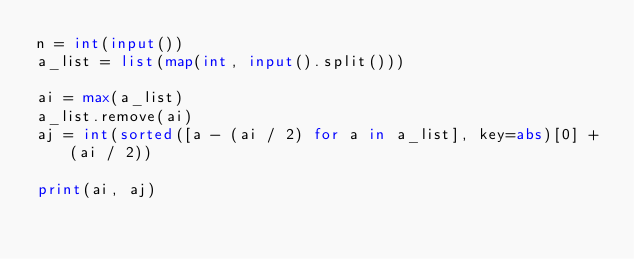Convert code to text. <code><loc_0><loc_0><loc_500><loc_500><_Python_>n = int(input())
a_list = list(map(int, input().split()))

ai = max(a_list)
a_list.remove(ai)
aj = int(sorted([a - (ai / 2) for a in a_list], key=abs)[0] + (ai / 2))

print(ai, aj)</code> 